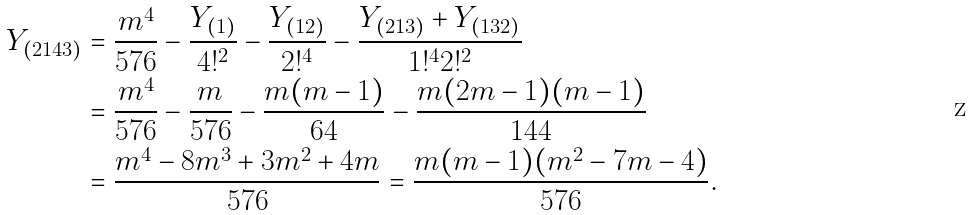Convert formula to latex. <formula><loc_0><loc_0><loc_500><loc_500>Y _ { ( 2 1 4 3 ) } & = \frac { m ^ { 4 } } { 5 7 6 } - \frac { Y _ { ( 1 ) } } { 4 ! ^ { 2 } } - \frac { Y _ { ( 1 2 ) } } { 2 ! ^ { 4 } } - \frac { Y _ { ( 2 1 3 ) } + Y _ { ( 1 3 2 ) } } { 1 ! ^ { 4 } 2 ! ^ { 2 } } \\ & = \frac { m ^ { 4 } } { 5 7 6 } - \frac { m } { 5 7 6 } - \frac { m ( m - 1 ) } { 6 4 } - \frac { m ( 2 m - 1 ) ( m - 1 ) } { 1 4 4 } \\ & = \frac { m ^ { 4 } - 8 m ^ { 3 } + 3 m ^ { 2 } + 4 m } { 5 7 6 } = \frac { m ( m - 1 ) ( m ^ { 2 } - 7 m - 4 ) } { 5 7 6 } .</formula> 